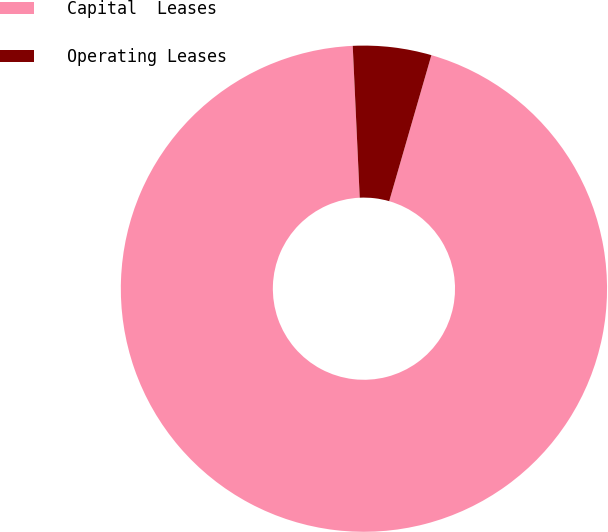Convert chart. <chart><loc_0><loc_0><loc_500><loc_500><pie_chart><fcel>Capital  Leases<fcel>Operating Leases<nl><fcel>94.79%<fcel>5.21%<nl></chart> 